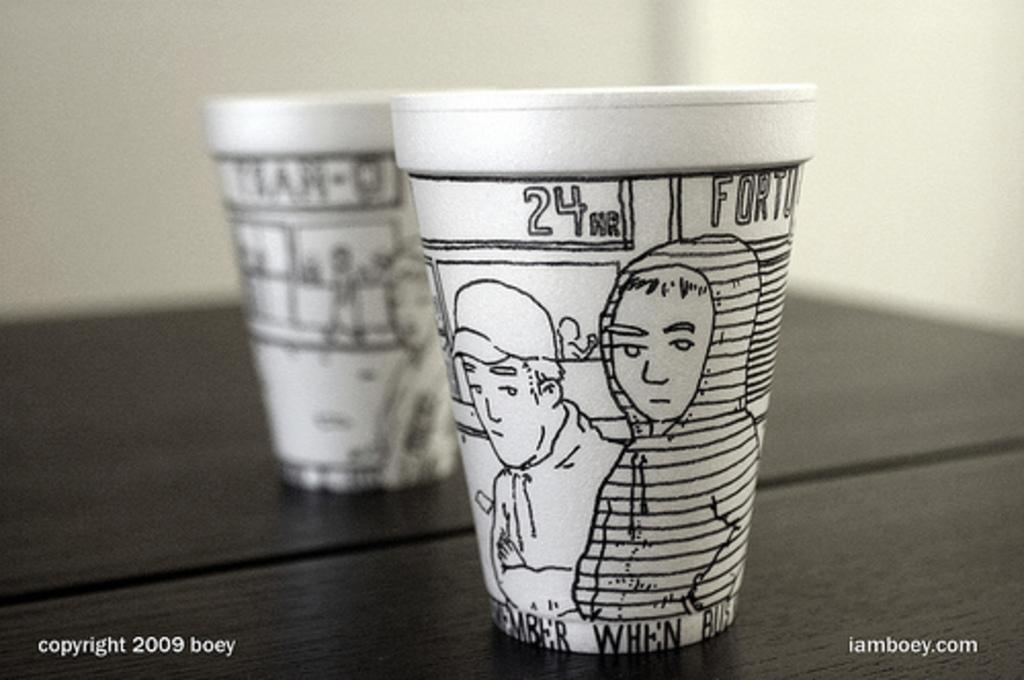What type of cup is in the image? There is a white coffee cup in the image. What is depicted on the coffee cup? The coffee cup has sketches of humans on it. Is there any reflective surface in the image? Yes, there is an image visible in a mirror. What type of scent can be smelled from the coffee cup in the image? There is no information about the scent of the coffee cup in the image, as it only provides visual details. 